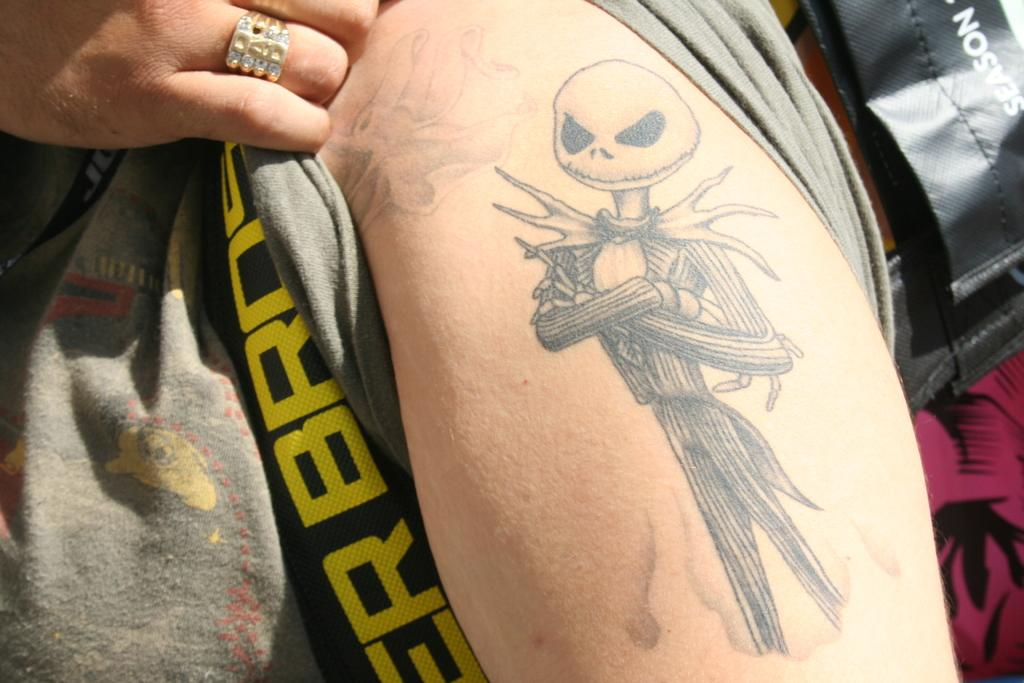What part of a person's body is visible in the image? There is a person's hand in the image. What can be observed about the person's hand? The person's hand has fingers. Is there any jewelry visible on the person's hand? Yes, there is a ring on the person's hand. What else can be seen in the image besides the person's hand? There are objects in the image. Are there any additional features on the person's hand? Yes, the person's hand has a tattoo. What type of coil is being used to make the pickle cream in the image? There is no coil, pickle, or cream present in the image; it only features a person's hand with a ring, fingers, and a tattoo. 